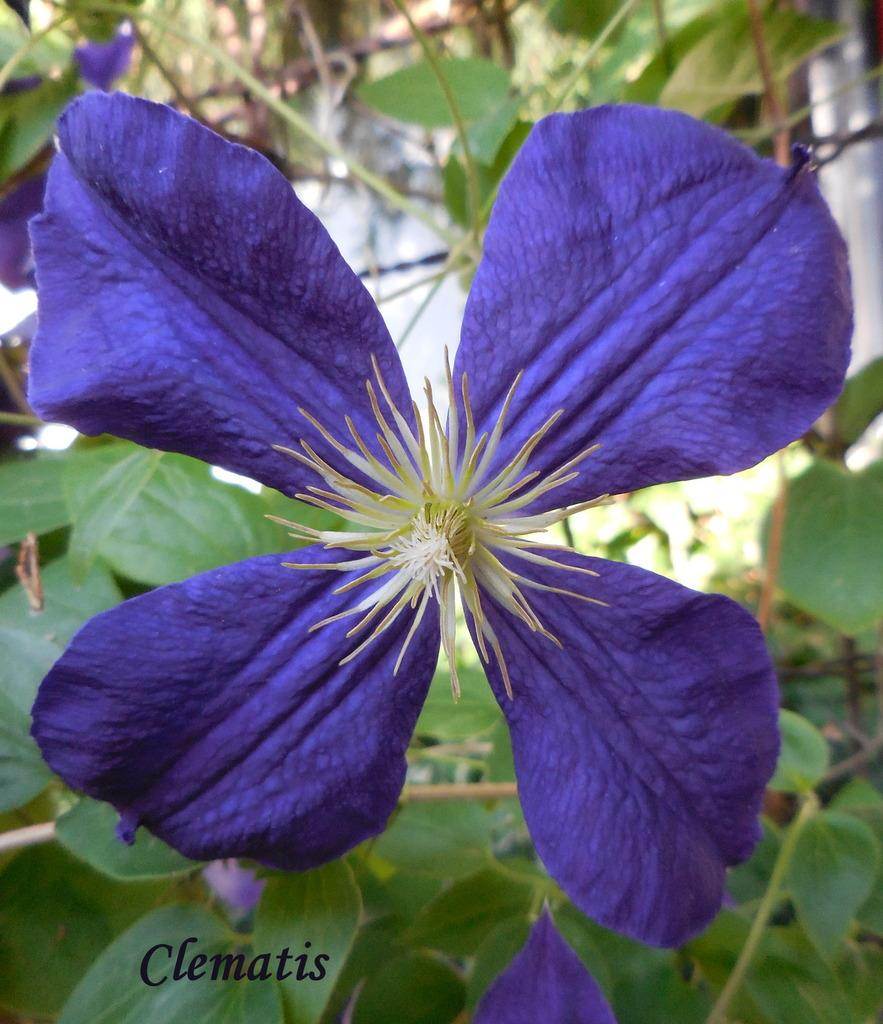What type of living organisms can be seen in the image? There are flowers and plants visible in the image. What is the main structure in the image? There is a wall in the image. How would you describe the background of the image? The background of the image is blurred. Is there any text present in the image? Yes, there is some text at the bottom of the image. What type of veil can be seen covering the dolls in the image? There are no dolls or veils present in the image; it features flowers, plants, a wall, and text. 